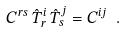Convert formula to latex. <formula><loc_0><loc_0><loc_500><loc_500>C ^ { r s } \, \hat { T } ^ { i } _ { \, r } \, \hat { T } ^ { j } _ { \, s } = C ^ { i j } \ .</formula> 